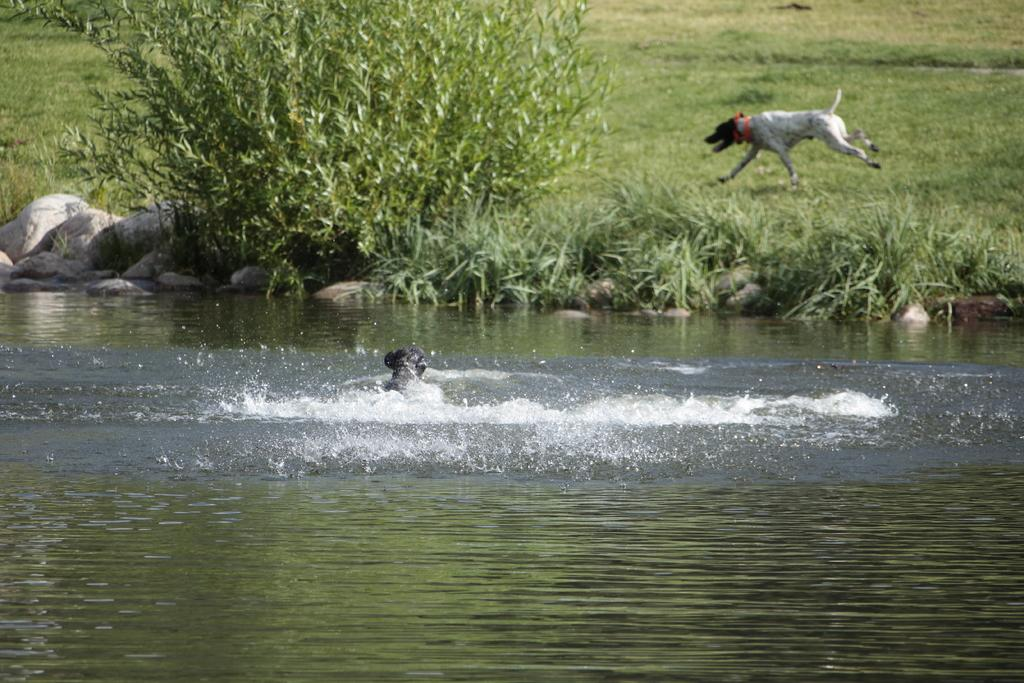What is the animal doing in the water? The animal is in the water, but the specific action is not mentioned in the facts. What can be found near the river? There are rocks near the river. What type of vegetation is visible in the image? There are trees visible in the image. What is the dog doing in the image? A dog is running on the grass in the image. Is there a boat floating on the water in the image? No, there is no mention of a boat in the image. What type of event is taking place near the trees? There is no event mentioned in the image; it only shows an animal in the water, rocks near the river, trees, and a dog running on the grass. 